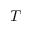<formula> <loc_0><loc_0><loc_500><loc_500>T</formula> 